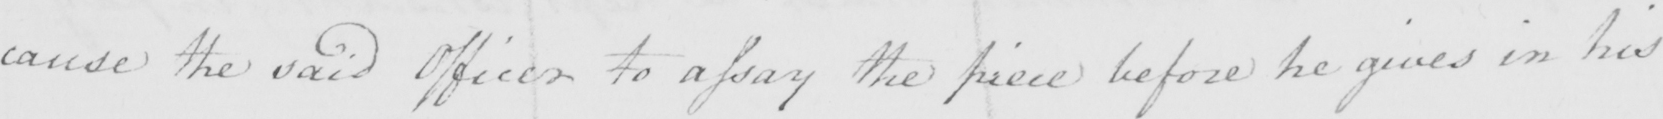Can you read and transcribe this handwriting? cause the said Officer to assay the piece before he gives in his 